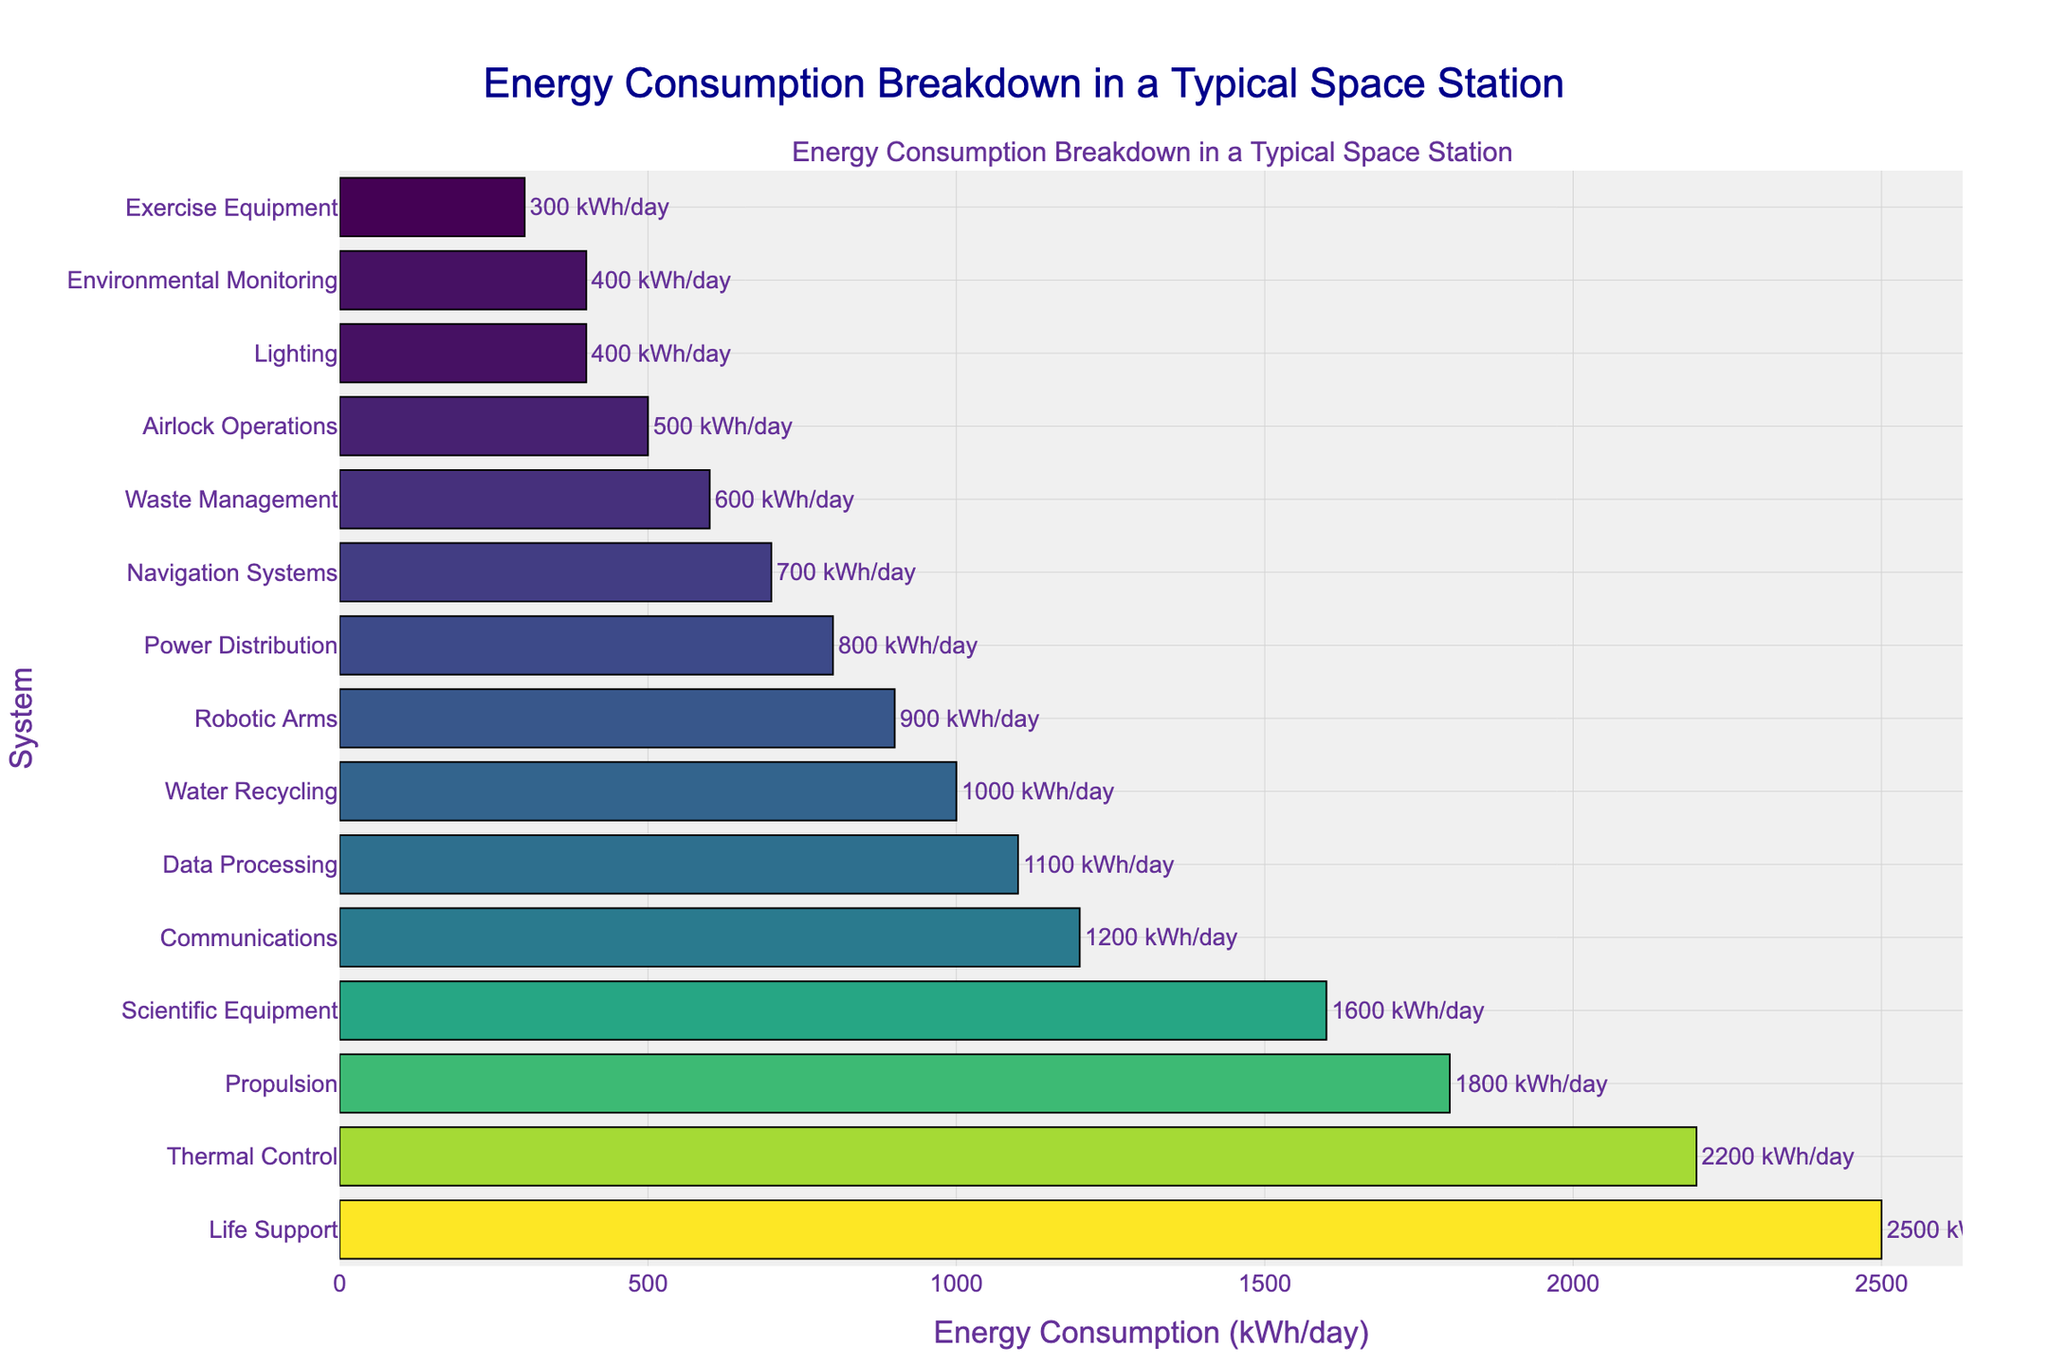What is the system with the highest energy consumption? To determine which system has the highest energy consumption, look for the longest bar in the bar chart. The longest bar corresponds to the "Life Support" system.
Answer: Life Support Which systems consume less than 500 kWh/day? To find the systems consuming less than 500 kWh/day, look for the bars with values below 500 kWh in the chart. These systems are "Lighting", "Exercise Equipment", and "Environmental Monitoring".
Answer: Lighting, Exercise Equipment, Environmental Monitoring How much more energy does the Life Support system consume compared to the Propulsion system? Find the energy consumption values for the Life Support and Propulsion systems. Life Support consumes 2500 kWh/day and Propulsion consumes 1800 kWh/day. Subtract the Propulsion value from the Life Support value: 2500 - 1800 = 700.
Answer: 700 kWh/day Which system has the lowest energy consumption, and what is its value? Locate the shortest bar in the chart to find the system with the lowest energy consumption, which is "Exercise Equipment" with 300 kWh/day.
Answer: Exercise Equipment, 300 kWh/day What is the total energy consumption of the Life Support, Propulsion, and Scientific Equipment systems combined? Add the energy consumption values of Life Support (2500 kWh/day), Propulsion (1800 kWh/day), and Scientific Equipment (1600 kWh/day): 2500 + 1800 + 1600 = 5900.
Answer: 5900 kWh/day Compare the energy consumption of the Thermal Control system to the Water Recycling system. Which one consumes more and by how much? Check the energy consumption values for Thermal Control and Water Recycling. Thermal Control consumes 2200 kWh/day, while Water Recycling consumes 1000 kWh/day. Subtract the Water Recycling value from Thermal Control: 2200 - 1000 = 1200.
Answer: Thermal Control, 1200 kWh/day What is the average energy consumption of the systems? To find the average, sum the energy consumption values of all systems and divide by the number of systems. The total energy is 19500 kWh/day (sum of all provided consumption values). There are 15 systems, so 19500 / 15 = 1300.
Answer: 1300 kWh/day Which systems have energy consumptions within 100 kWh/day of each other? Identify the systems with energy consumption values close to each other by inspecting the bar lengths. "Airlock Operations" (500 kWh/day) and "Environmental Monitoring" (400 kWh/day) are within 100 kWh/day of each other.
Answer: Airlock Operations, Environmental Monitoring What color represents the highest energy consumption in the chart? The color used for the highest energy consumption bar (Life Support) in the chart is indicative of the chart's color scaling. In this case, it may be the darkest or most intense color in the "Viridis" colorscale.
Answer: Likely the darkest or most intense color in the Viridis scale What proportion of the total energy consumption is used by the Life Support system? Calculate the total energy consumption (19500 kWh/day) and the Life Support consumption (2500 kWh/day). The proportion is 2500 / 19500 = 0.1282, or approximately 12.82%.
Answer: 12.82% 